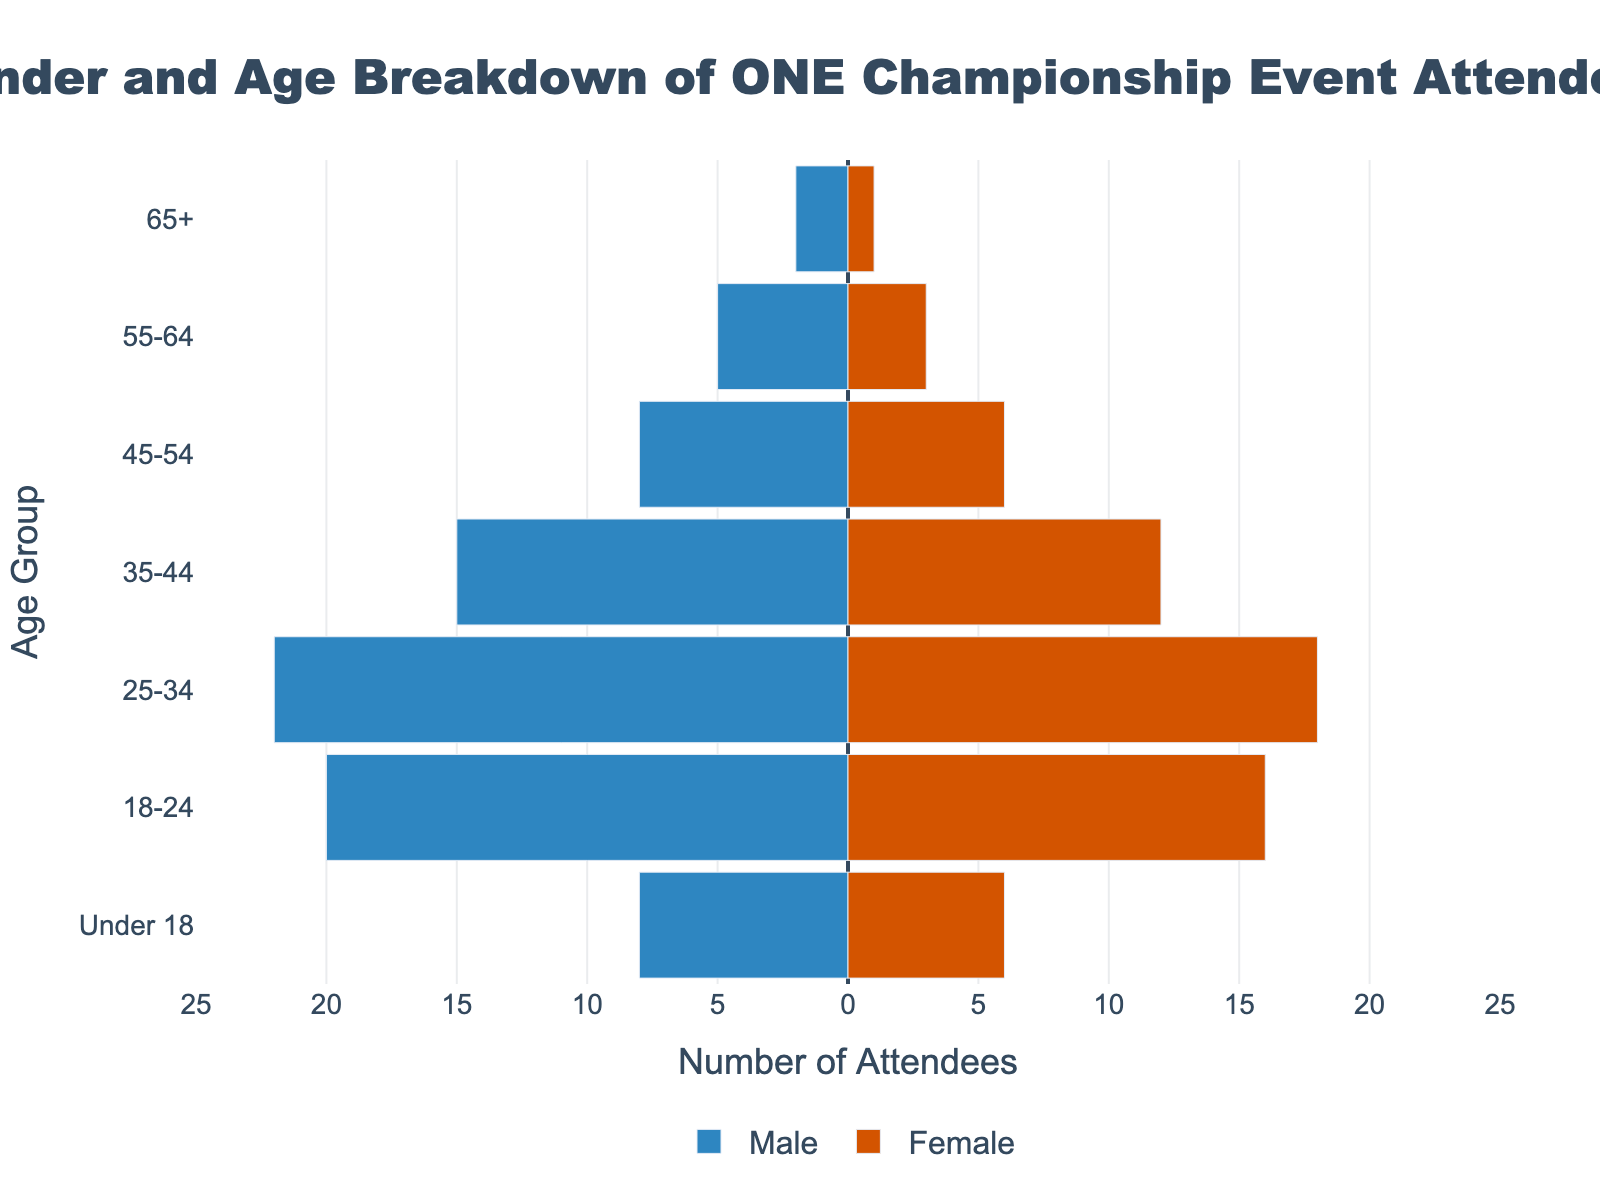What's the title of the figure? The title of the figure is located at the top center in large font, indicating the overall subject.
Answer: Gender and Age Breakdown of ONE Championship Event Attendees What is the color used to represent males in the chart? The colors used in the chart differentiate between genders, and the color for males is specified in the legend or visually.
Answer: Blue How many females are in the 25-34 age group? For females in the 25-34 age group, locate the corresponding bar and read the value.
Answer: 18 Which age group has the smallest number of male attendees? Identify the shortest bar for males and read the age group it corresponds to.
Answer: 65+ What is the total number of male attendees for all age groups combined? Add the absolute values of all the male bars: 2 + 5 + 8 + 15 + 22 + 20 + 8
Answer: 80 Which age group has more attendees, 18-24 or 25-34? Compare the lengths of the bars for the 18-24 and 25-34 age groups and sum the male and female counts for each group: 36 (18-24) vs 40 (25-34)
Answer: 25-34 Is the distribution of male and female attendees roughly equal in the 35-44 age group? Compare the lengths of the male and female bars in the 35-44 age group: 15 (male) vs 12 (female)
Answer: No What is the combined number of attendees over 55 years old? Add the numbers for both genders over 55 years old: (5 + 2) for 55-64 and (3 + 1) for 65+
Answer: 11 How does the number of male attendees in the 18-24 age group compare to those under 18? Compare the lengths of the male bars for the 18-24 and Under 18 age groups: 20 vs 8
Answer: More in 18-24 What is the total number of attendees in the age group with the most people? Identify the age group with the longest combined bars for males and females: 25-34. Sum the male and female attendees: 22 + 18 = 40
Answer: 40 